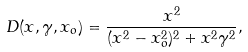Convert formula to latex. <formula><loc_0><loc_0><loc_500><loc_500>D ( x , \gamma , x _ { o } ) = \frac { x ^ { 2 } } { ( x ^ { 2 } - x _ { o } ^ { 2 } ) ^ { 2 } + x ^ { 2 } \gamma ^ { 2 } } ,</formula> 